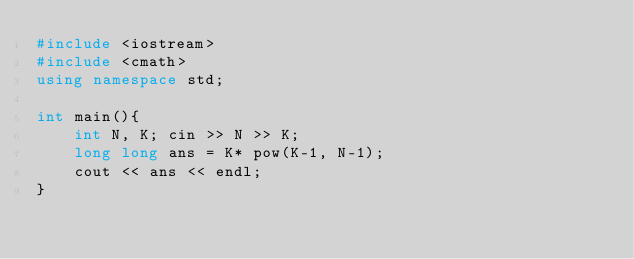Convert code to text. <code><loc_0><loc_0><loc_500><loc_500><_C++_>#include <iostream>
#include <cmath>
using namespace std;

int main(){
    int N, K; cin >> N >> K;
    long long ans = K* pow(K-1, N-1);
    cout << ans << endl;
}</code> 